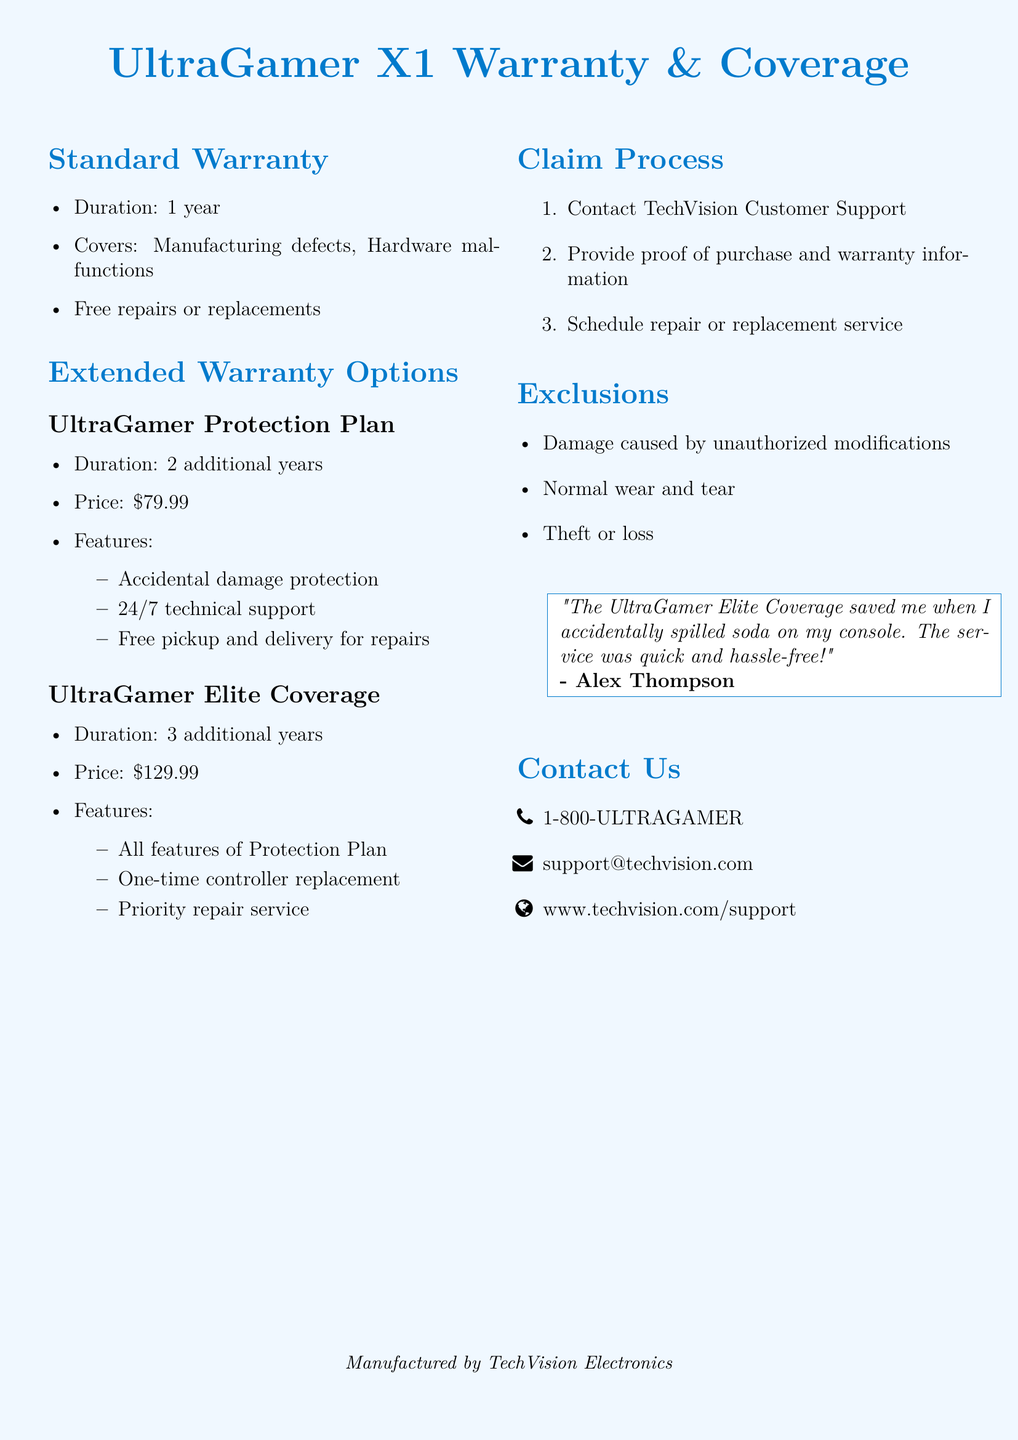What is the duration of the standard warranty? The standard warranty lasts for one year.
Answer: 1 year What is the price of the UltraGamer Protection Plan? The UltraGamer Protection Plan costs seventy-nine dollars and ninety-nine cents.
Answer: $79.99 What does the UltraGamer Elite Coverage include that the Protection Plan does not? The Elite Coverage includes a one-time controller replacement, which is not included in the Protection Plan.
Answer: One-time controller replacement What should you provide to claim warranty service? You should provide proof of purchase and warranty information to claim warranty service.
Answer: Proof of purchase and warranty information What type of damage is excluded from coverage? Damage caused by unauthorized modifications is one of the exclusions from the coverage.
Answer: Unauthorized modifications How many additional years does the UltraGamer Elite Coverage provide? The UltraGamer Elite Coverage provides three additional years beyond the standard warranty.
Answer: 3 years What type of support is offered 24/7 with the Protection Plan? The Protection Plan offers 24/7 technical support.
Answer: Technical support What is the process to get a repair under warranty? The claim process involves contacting TechVision Customer Support first.
Answer: Contact TechVision Customer Support 